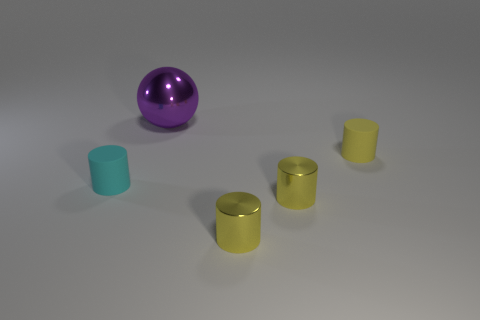Subtract all cyan cylinders. How many cylinders are left? 3 Add 4 purple metal spheres. How many objects exist? 9 Subtract 1 spheres. How many spheres are left? 0 Subtract all cyan cylinders. How many cylinders are left? 3 Subtract 0 brown blocks. How many objects are left? 5 Subtract all spheres. How many objects are left? 4 Subtract all green cylinders. Subtract all gray blocks. How many cylinders are left? 4 Subtract all purple cubes. How many cyan cylinders are left? 1 Subtract all brown balls. Subtract all yellow things. How many objects are left? 2 Add 2 small metal cylinders. How many small metal cylinders are left? 4 